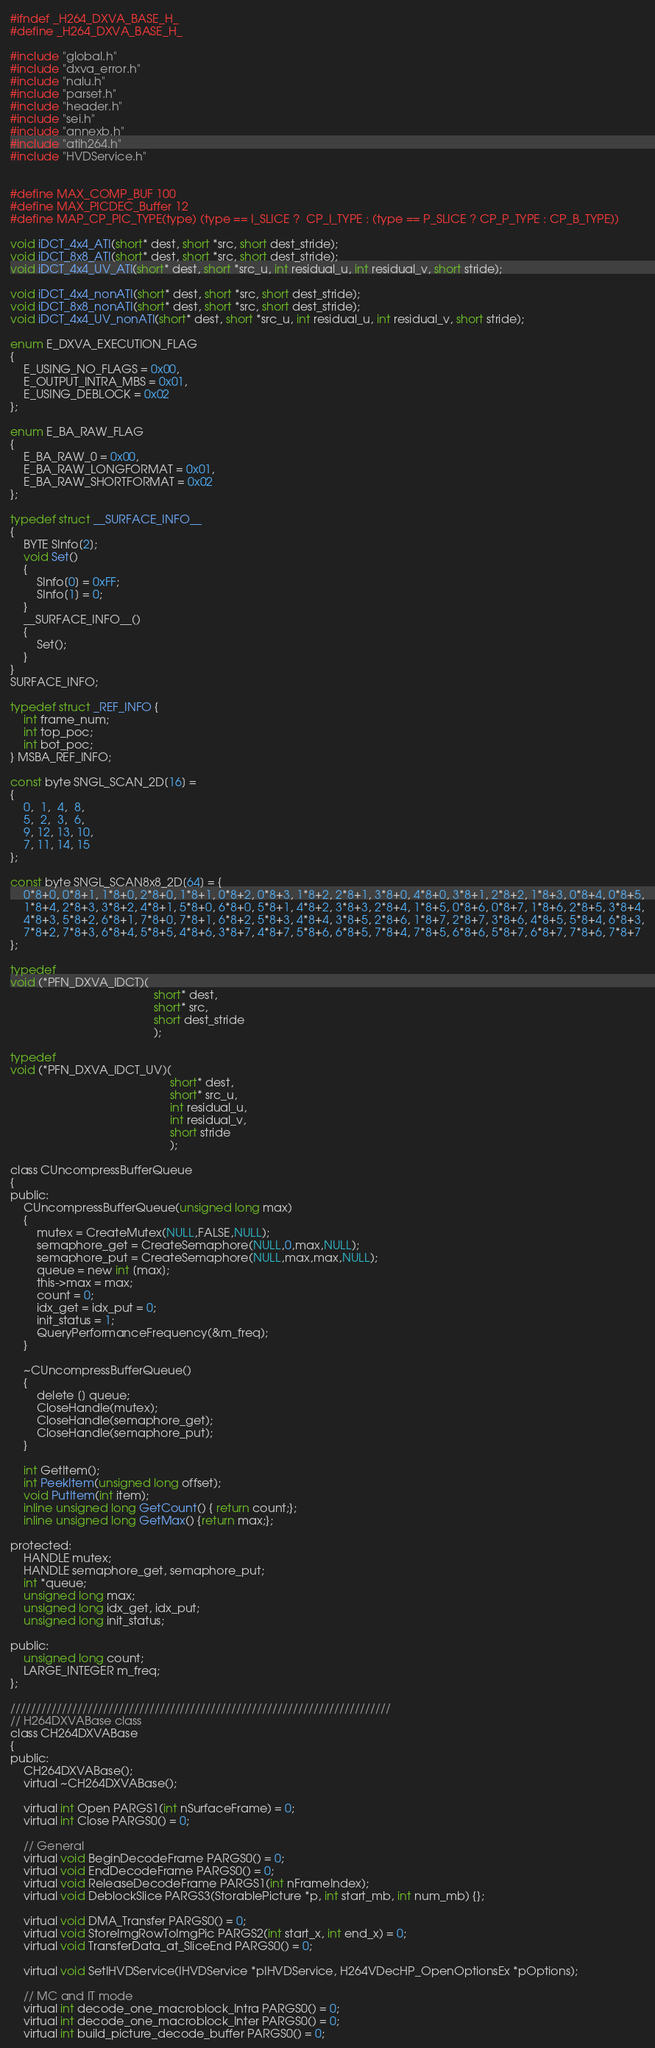<code> <loc_0><loc_0><loc_500><loc_500><_C_>#ifndef _H264_DXVA_BASE_H_
#define _H264_DXVA_BASE_H_

#include "global.h"
#include "dxva_error.h"
#include "nalu.h"
#include "parset.h"
#include "header.h"
#include "sei.h"
#include "annexb.h"
#include "atih264.h"
#include "HVDService.h"


#define MAX_COMP_BUF 100
#define MAX_PICDEC_Buffer 12
#define MAP_CP_PIC_TYPE(type) (type == I_SLICE ?  CP_I_TYPE : (type == P_SLICE ? CP_P_TYPE : CP_B_TYPE))

void iDCT_4x4_ATI(short* dest, short *src, short dest_stride);
void iDCT_8x8_ATI(short* dest, short *src, short dest_stride);
void iDCT_4x4_UV_ATI(short* dest, short *src_u, int residual_u, int residual_v, short stride);

void iDCT_4x4_nonATI(short* dest, short *src, short dest_stride);
void iDCT_8x8_nonATI(short* dest, short *src, short dest_stride);
void iDCT_4x4_UV_nonATI(short* dest, short *src_u, int residual_u, int residual_v, short stride);

enum E_DXVA_EXECUTION_FLAG
{
	E_USING_NO_FLAGS = 0x00,
	E_OUTPUT_INTRA_MBS = 0x01,
	E_USING_DEBLOCK = 0x02
};

enum E_BA_RAW_FLAG
{
	E_BA_RAW_0 = 0x00,
	E_BA_RAW_LONGFORMAT = 0x01,
	E_BA_RAW_SHORTFORMAT = 0x02
};

typedef struct __SURFACE_INFO__
{
	BYTE SInfo[2];
	void Set()
	{
		SInfo[0] = 0xFF;
		SInfo[1] = 0;
	}
	__SURFACE_INFO__()
	{
		Set();
	}
}
SURFACE_INFO;

typedef struct _REF_INFO {
	int frame_num;
	int top_poc;
	int bot_poc;
} MSBA_REF_INFO;

const byte SNGL_SCAN_2D[16] =
{
	0,  1,  4,  8,
	5,  2,  3,  6,
	9, 12, 13, 10,
	7, 11, 14, 15
};

const byte SNGL_SCAN8x8_2D[64] = {  
	0*8+0, 0*8+1, 1*8+0, 2*8+0, 1*8+1, 0*8+2, 0*8+3, 1*8+2, 2*8+1, 3*8+0, 4*8+0, 3*8+1, 2*8+2, 1*8+3, 0*8+4, 0*8+5,
	1*8+4, 2*8+3, 3*8+2, 4*8+1, 5*8+0, 6*8+0, 5*8+1, 4*8+2, 3*8+3, 2*8+4, 1*8+5, 0*8+6, 0*8+7, 1*8+6, 2*8+5, 3*8+4,
	4*8+3, 5*8+2, 6*8+1, 7*8+0, 7*8+1, 6*8+2, 5*8+3, 4*8+4, 3*8+5, 2*8+6, 1*8+7, 2*8+7, 3*8+6, 4*8+5, 5*8+4, 6*8+3,
	7*8+2, 7*8+3, 6*8+4, 5*8+5, 4*8+6, 3*8+7, 4*8+7, 5*8+6, 6*8+5, 7*8+4, 7*8+5, 6*8+6, 5*8+7, 6*8+7, 7*8+6, 7*8+7
};

typedef
void (*PFN_DXVA_IDCT)(
											short* dest,
											short* src,
											short dest_stride
											);

typedef
void (*PFN_DXVA_IDCT_UV)(
												 short* dest,
												 short* src_u,
												 int residual_u,
												 int residual_v,
												 short stride
												 );

class CUncompressBufferQueue
{
public:
	CUncompressBufferQueue(unsigned long max)
	{
		mutex = CreateMutex(NULL,FALSE,NULL);
		semaphore_get = CreateSemaphore(NULL,0,max,NULL);
		semaphore_put = CreateSemaphore(NULL,max,max,NULL);
		queue = new int [max];
		this->max = max;
		count = 0;
		idx_get = idx_put = 0;
		init_status = 1;
		QueryPerformanceFrequency(&m_freq);
	}

	~CUncompressBufferQueue()
	{
		delete [] queue;
		CloseHandle(mutex);
		CloseHandle(semaphore_get);
		CloseHandle(semaphore_put);
	}

	int GetItem();
	int PeekItem(unsigned long offset);
	void PutItem(int item);
	inline unsigned long GetCount() { return count;};
	inline unsigned long GetMax() {return max;};

protected:
	HANDLE mutex;
	HANDLE semaphore_get, semaphore_put;
	int *queue;
	unsigned long max;
	unsigned long idx_get, idx_put;
	unsigned long init_status;

public:
	unsigned long count;
	LARGE_INTEGER m_freq;
};

//////////////////////////////////////////////////////////////////////////
// H264DXVABase class
class CH264DXVABase
{
public:
	CH264DXVABase();
	virtual ~CH264DXVABase();

	virtual int Open PARGS1(int nSurfaceFrame) = 0;
	virtual int Close PARGS0() = 0;

	// General
	virtual void BeginDecodeFrame PARGS0() = 0;
	virtual void EndDecodeFrame PARGS0() = 0;
	virtual void ReleaseDecodeFrame PARGS1(int nFrameIndex);
	virtual void DeblockSlice PARGS3(StorablePicture *p, int start_mb, int num_mb) {};

	virtual void DMA_Transfer PARGS0() = 0;
	virtual void StoreImgRowToImgPic PARGS2(int start_x, int end_x) = 0;
	virtual void TransferData_at_SliceEnd PARGS0() = 0;

	virtual void SetIHVDService(IHVDService *pIHVDService, H264VDecHP_OpenOptionsEx *pOptions);

	// MC and IT mode
	virtual int decode_one_macroblock_Intra PARGS0() = 0;
	virtual int decode_one_macroblock_Inter PARGS0() = 0;
	virtual int build_picture_decode_buffer PARGS0() = 0;</code> 